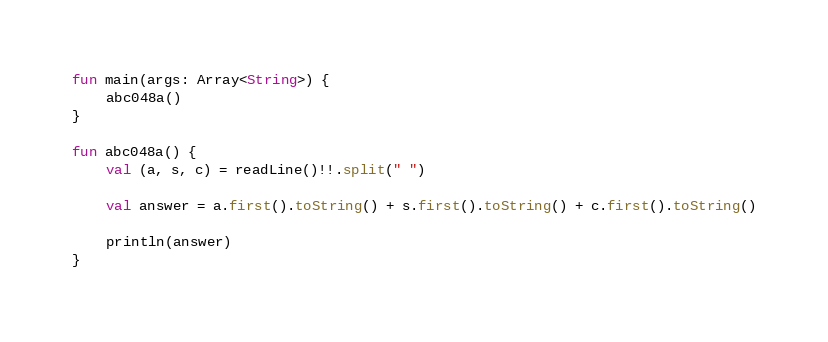Convert code to text. <code><loc_0><loc_0><loc_500><loc_500><_Kotlin_>fun main(args: Array<String>) {
    abc048a()
}

fun abc048a() {
    val (a, s, c) = readLine()!!.split(" ")

    val answer = a.first().toString() + s.first().toString() + c.first().toString()

    println(answer)
}
</code> 